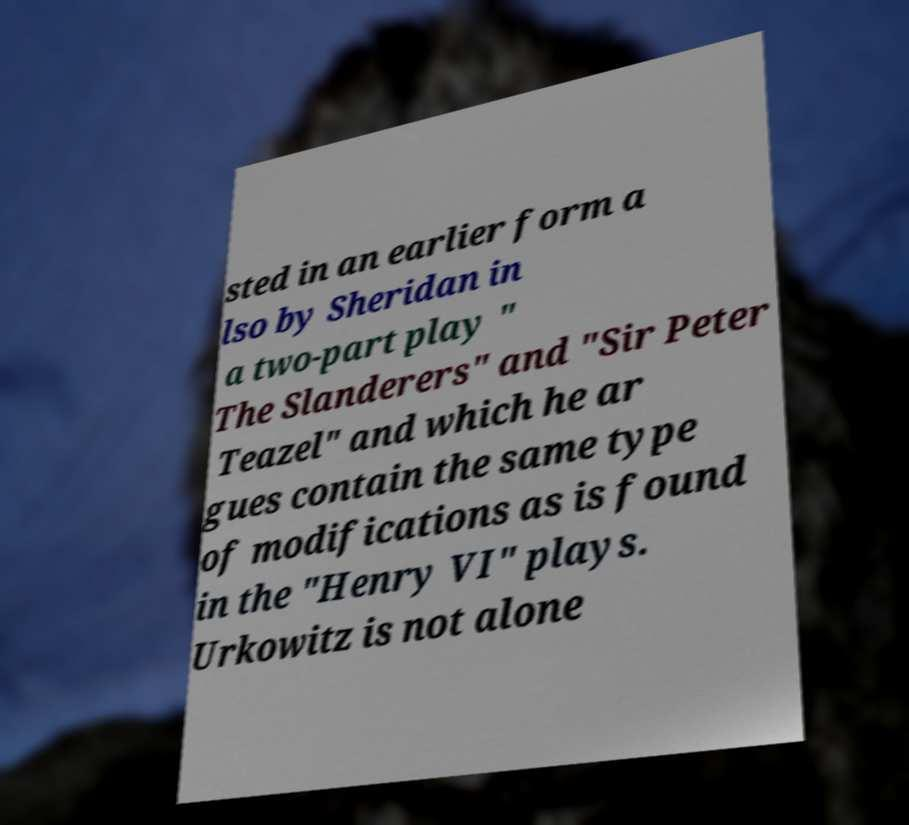Please identify and transcribe the text found in this image. sted in an earlier form a lso by Sheridan in a two-part play " The Slanderers" and "Sir Peter Teazel" and which he ar gues contain the same type of modifications as is found in the "Henry VI" plays. Urkowitz is not alone 